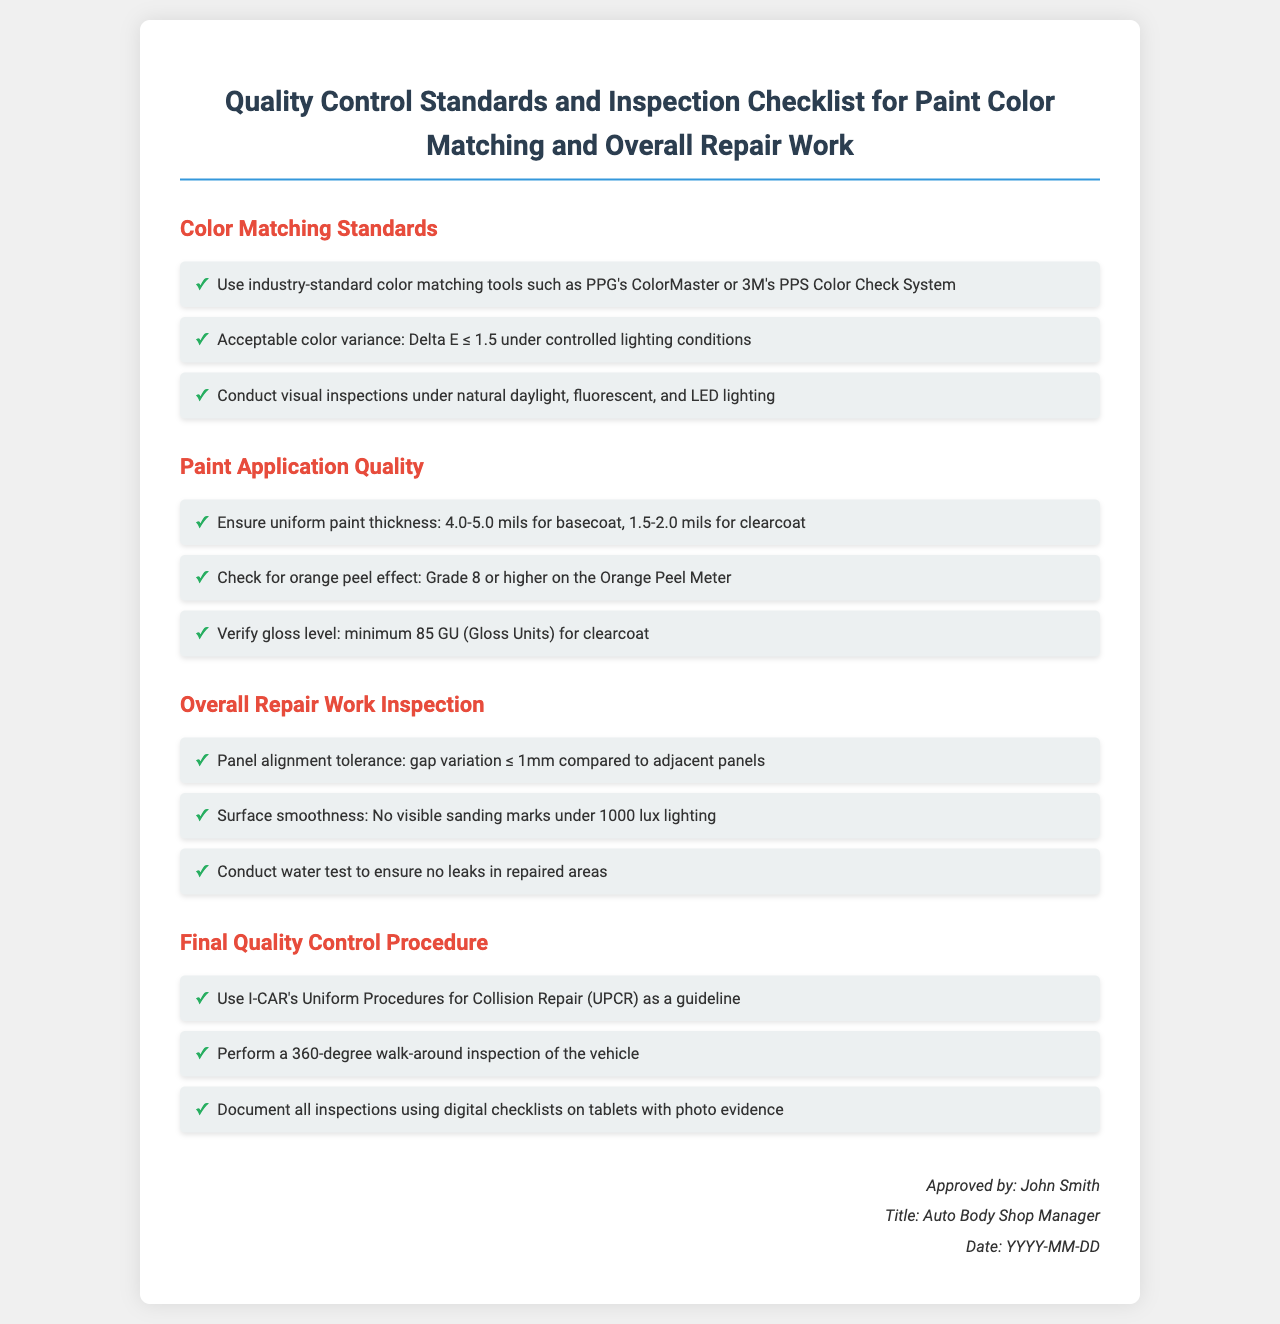what is the acceptable color variance? The acceptable color variance is specified in the document as Delta E ≤ 1.5 under controlled lighting conditions.
Answer: Delta E ≤ 1.5 what tools are recommended for color matching? The recommended tools for color matching mentioned in the document are PPG's ColorMaster or 3M's PPS Color Check System.
Answer: PPG's ColorMaster or 3M's PPS Color Check System what is the required gloss level for clearcoat? The document states the minimum gloss level for clearcoat must be 85 GU (Gloss Units).
Answer: 85 GU what is the panel alignment tolerance? The panel alignment tolerance specified is gap variation ≤ 1mm compared to adjacent panels.
Answer: gap variation ≤ 1mm how should the paint thickness be for the basecoat? The document specifies that the uniform paint thickness for the basecoat should be between 4.0-5.0 mils.
Answer: 4.0-5.0 mils what type of inspection is conducted to ensure no leaks? The water test is specified in the document as the inspection conducted to ensure no leaks in repaired areas.
Answer: water test who approved the quality control standards? The approver of the quality control standards mentioned is John Smith.
Answer: John Smith what is the time frame indicated for the document approval date? The document indicates that the approval date format is YYYY-MM-DD, which suggests a time frame is mentioned but not specifically stated.
Answer: YYYY-MM-DD what grading is required for the orange peel effect? The document requires an orange peel effect grading of Grade 8 or higher on the Orange Peel Meter.
Answer: Grade 8 or higher 